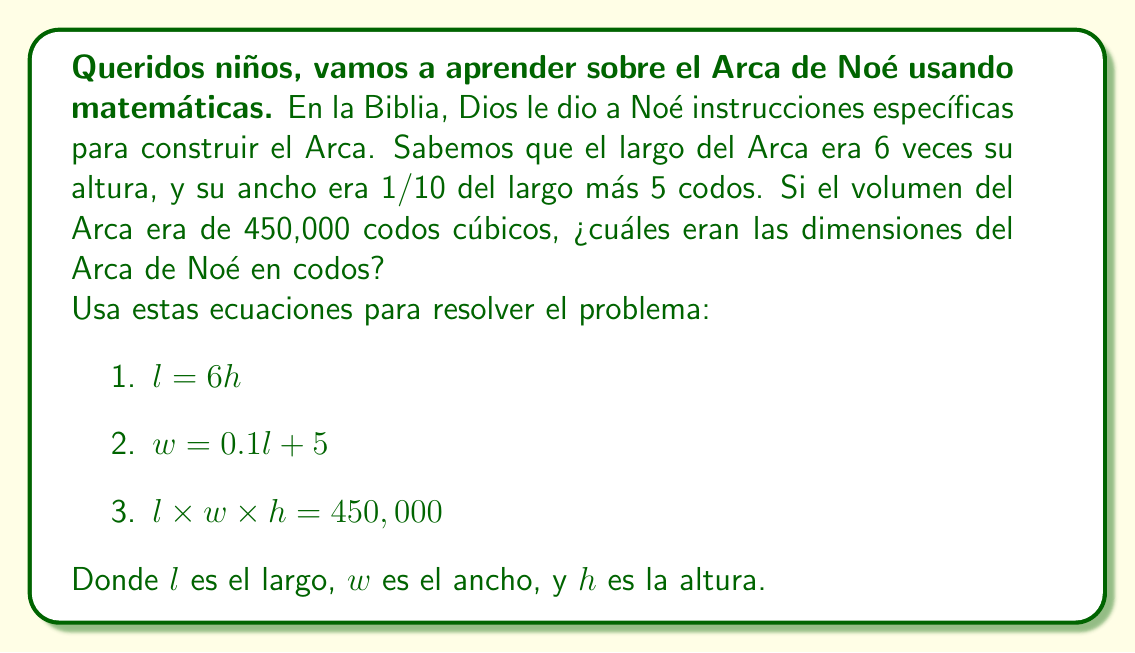Help me with this question. Vamos a resolver este problema paso a paso, niños. Recordemos que Dios nos dio la inteligencia para entender Su creación.

1) Primero, sustituimos $l$ en la ecuación 2 usando la ecuación 1:
   $w = 0.1(6h) + 5 = 0.6h + 5$

2) Ahora, usamos estas expresiones en la ecuación 3:
   $(6h) \times (0.6h + 5) \times h = 450,000$

3) Simplificamos:
   $6h \times (0.6h + 5) \times h = 450,000$
   $3.6h^3 + 30h^2 = 450,000$

4) Dividimos todo por 3.6:
   $h^3 + 8.33h^2 = 125,000$

5) Esta es una ecuación cúbica. Podemos resolverla por prueba y error o usando una calculadora. La solución es:
   $h = 30$ codos

6) Ahora que tenemos $h$, podemos calcular $l$ y $w$:
   $l = 6h = 6 \times 30 = 180$ codos
   $w = 0.1l + 5 = 0.1 \times 180 + 5 = 23$ codos

Así, Dios en Su infinita sabiduría, guió a Noé para construir un Arca perfectamente proporcionada.
Answer: Las dimensiones del Arca de Noé eran:
Largo ($l$): 180 codos
Ancho ($w$): 23 codos
Altura ($h$): 30 codos 